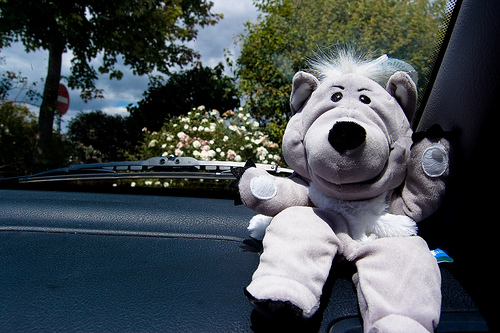<image>
Is there a toy on the car? Yes. Looking at the image, I can see the toy is positioned on top of the car, with the car providing support. 